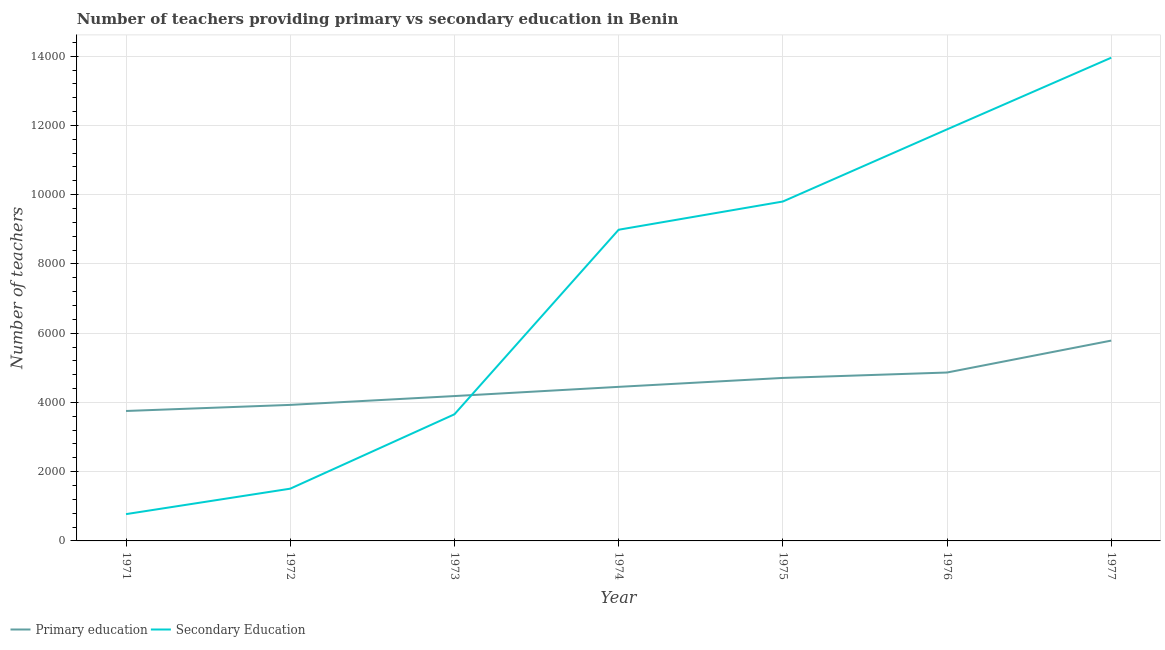Does the line corresponding to number of primary teachers intersect with the line corresponding to number of secondary teachers?
Your answer should be compact. Yes. Is the number of lines equal to the number of legend labels?
Make the answer very short. Yes. What is the number of primary teachers in 1973?
Your answer should be very brief. 4184. Across all years, what is the maximum number of primary teachers?
Give a very brief answer. 5786. Across all years, what is the minimum number of primary teachers?
Provide a short and direct response. 3753. In which year was the number of primary teachers maximum?
Give a very brief answer. 1977. What is the total number of primary teachers in the graph?
Your answer should be compact. 3.17e+04. What is the difference between the number of primary teachers in 1971 and that in 1972?
Ensure brevity in your answer.  -176. What is the difference between the number of primary teachers in 1971 and the number of secondary teachers in 1973?
Keep it short and to the point. 96. What is the average number of primary teachers per year?
Provide a succinct answer. 4524.86. In the year 1974, what is the difference between the number of secondary teachers and number of primary teachers?
Provide a short and direct response. 4538. In how many years, is the number of secondary teachers greater than 2800?
Give a very brief answer. 5. What is the ratio of the number of secondary teachers in 1972 to that in 1974?
Your response must be concise. 0.17. Is the number of primary teachers in 1971 less than that in 1974?
Your answer should be compact. Yes. Is the difference between the number of primary teachers in 1973 and 1974 greater than the difference between the number of secondary teachers in 1973 and 1974?
Your answer should be very brief. Yes. What is the difference between the highest and the second highest number of primary teachers?
Offer a terse response. 922. What is the difference between the highest and the lowest number of secondary teachers?
Provide a succinct answer. 1.32e+04. Is the number of secondary teachers strictly less than the number of primary teachers over the years?
Provide a short and direct response. No. How many lines are there?
Your response must be concise. 2. How many years are there in the graph?
Provide a short and direct response. 7. Are the values on the major ticks of Y-axis written in scientific E-notation?
Provide a succinct answer. No. Does the graph contain any zero values?
Provide a succinct answer. No. Where does the legend appear in the graph?
Make the answer very short. Bottom left. How are the legend labels stacked?
Give a very brief answer. Horizontal. What is the title of the graph?
Provide a short and direct response. Number of teachers providing primary vs secondary education in Benin. Does "Young" appear as one of the legend labels in the graph?
Give a very brief answer. No. What is the label or title of the Y-axis?
Your answer should be very brief. Number of teachers. What is the Number of teachers in Primary education in 1971?
Offer a very short reply. 3753. What is the Number of teachers in Secondary Education in 1971?
Ensure brevity in your answer.  774. What is the Number of teachers in Primary education in 1972?
Offer a terse response. 3929. What is the Number of teachers in Secondary Education in 1972?
Your response must be concise. 1509. What is the Number of teachers of Primary education in 1973?
Make the answer very short. 4184. What is the Number of teachers in Secondary Education in 1973?
Your response must be concise. 3657. What is the Number of teachers of Primary education in 1974?
Your response must be concise. 4450. What is the Number of teachers in Secondary Education in 1974?
Make the answer very short. 8988. What is the Number of teachers in Primary education in 1975?
Your answer should be compact. 4708. What is the Number of teachers in Secondary Education in 1975?
Provide a short and direct response. 9803. What is the Number of teachers of Primary education in 1976?
Keep it short and to the point. 4864. What is the Number of teachers of Secondary Education in 1976?
Make the answer very short. 1.19e+04. What is the Number of teachers in Primary education in 1977?
Your response must be concise. 5786. What is the Number of teachers in Secondary Education in 1977?
Offer a terse response. 1.40e+04. Across all years, what is the maximum Number of teachers in Primary education?
Ensure brevity in your answer.  5786. Across all years, what is the maximum Number of teachers of Secondary Education?
Your response must be concise. 1.40e+04. Across all years, what is the minimum Number of teachers in Primary education?
Make the answer very short. 3753. Across all years, what is the minimum Number of teachers of Secondary Education?
Keep it short and to the point. 774. What is the total Number of teachers in Primary education in the graph?
Offer a very short reply. 3.17e+04. What is the total Number of teachers of Secondary Education in the graph?
Ensure brevity in your answer.  5.06e+04. What is the difference between the Number of teachers of Primary education in 1971 and that in 1972?
Ensure brevity in your answer.  -176. What is the difference between the Number of teachers in Secondary Education in 1971 and that in 1972?
Offer a very short reply. -735. What is the difference between the Number of teachers of Primary education in 1971 and that in 1973?
Offer a very short reply. -431. What is the difference between the Number of teachers in Secondary Education in 1971 and that in 1973?
Provide a short and direct response. -2883. What is the difference between the Number of teachers in Primary education in 1971 and that in 1974?
Offer a terse response. -697. What is the difference between the Number of teachers of Secondary Education in 1971 and that in 1974?
Give a very brief answer. -8214. What is the difference between the Number of teachers in Primary education in 1971 and that in 1975?
Make the answer very short. -955. What is the difference between the Number of teachers in Secondary Education in 1971 and that in 1975?
Provide a succinct answer. -9029. What is the difference between the Number of teachers of Primary education in 1971 and that in 1976?
Your response must be concise. -1111. What is the difference between the Number of teachers of Secondary Education in 1971 and that in 1976?
Offer a very short reply. -1.11e+04. What is the difference between the Number of teachers of Primary education in 1971 and that in 1977?
Your answer should be compact. -2033. What is the difference between the Number of teachers of Secondary Education in 1971 and that in 1977?
Your response must be concise. -1.32e+04. What is the difference between the Number of teachers in Primary education in 1972 and that in 1973?
Give a very brief answer. -255. What is the difference between the Number of teachers of Secondary Education in 1972 and that in 1973?
Provide a short and direct response. -2148. What is the difference between the Number of teachers of Primary education in 1972 and that in 1974?
Keep it short and to the point. -521. What is the difference between the Number of teachers of Secondary Education in 1972 and that in 1974?
Your answer should be compact. -7479. What is the difference between the Number of teachers of Primary education in 1972 and that in 1975?
Your response must be concise. -779. What is the difference between the Number of teachers in Secondary Education in 1972 and that in 1975?
Your response must be concise. -8294. What is the difference between the Number of teachers in Primary education in 1972 and that in 1976?
Offer a terse response. -935. What is the difference between the Number of teachers of Secondary Education in 1972 and that in 1976?
Make the answer very short. -1.04e+04. What is the difference between the Number of teachers in Primary education in 1972 and that in 1977?
Your response must be concise. -1857. What is the difference between the Number of teachers in Secondary Education in 1972 and that in 1977?
Your answer should be very brief. -1.24e+04. What is the difference between the Number of teachers of Primary education in 1973 and that in 1974?
Make the answer very short. -266. What is the difference between the Number of teachers of Secondary Education in 1973 and that in 1974?
Ensure brevity in your answer.  -5331. What is the difference between the Number of teachers of Primary education in 1973 and that in 1975?
Your answer should be very brief. -524. What is the difference between the Number of teachers of Secondary Education in 1973 and that in 1975?
Provide a short and direct response. -6146. What is the difference between the Number of teachers in Primary education in 1973 and that in 1976?
Your response must be concise. -680. What is the difference between the Number of teachers in Secondary Education in 1973 and that in 1976?
Your answer should be very brief. -8230. What is the difference between the Number of teachers of Primary education in 1973 and that in 1977?
Your response must be concise. -1602. What is the difference between the Number of teachers of Secondary Education in 1973 and that in 1977?
Your answer should be very brief. -1.03e+04. What is the difference between the Number of teachers in Primary education in 1974 and that in 1975?
Give a very brief answer. -258. What is the difference between the Number of teachers of Secondary Education in 1974 and that in 1975?
Your response must be concise. -815. What is the difference between the Number of teachers of Primary education in 1974 and that in 1976?
Give a very brief answer. -414. What is the difference between the Number of teachers in Secondary Education in 1974 and that in 1976?
Provide a short and direct response. -2899. What is the difference between the Number of teachers of Primary education in 1974 and that in 1977?
Your answer should be very brief. -1336. What is the difference between the Number of teachers of Secondary Education in 1974 and that in 1977?
Offer a very short reply. -4969. What is the difference between the Number of teachers in Primary education in 1975 and that in 1976?
Your response must be concise. -156. What is the difference between the Number of teachers of Secondary Education in 1975 and that in 1976?
Your answer should be compact. -2084. What is the difference between the Number of teachers of Primary education in 1975 and that in 1977?
Offer a terse response. -1078. What is the difference between the Number of teachers of Secondary Education in 1975 and that in 1977?
Ensure brevity in your answer.  -4154. What is the difference between the Number of teachers of Primary education in 1976 and that in 1977?
Offer a very short reply. -922. What is the difference between the Number of teachers of Secondary Education in 1976 and that in 1977?
Offer a terse response. -2070. What is the difference between the Number of teachers of Primary education in 1971 and the Number of teachers of Secondary Education in 1972?
Offer a terse response. 2244. What is the difference between the Number of teachers of Primary education in 1971 and the Number of teachers of Secondary Education in 1973?
Offer a terse response. 96. What is the difference between the Number of teachers in Primary education in 1971 and the Number of teachers in Secondary Education in 1974?
Offer a terse response. -5235. What is the difference between the Number of teachers in Primary education in 1971 and the Number of teachers in Secondary Education in 1975?
Ensure brevity in your answer.  -6050. What is the difference between the Number of teachers of Primary education in 1971 and the Number of teachers of Secondary Education in 1976?
Your answer should be compact. -8134. What is the difference between the Number of teachers of Primary education in 1971 and the Number of teachers of Secondary Education in 1977?
Your response must be concise. -1.02e+04. What is the difference between the Number of teachers of Primary education in 1972 and the Number of teachers of Secondary Education in 1973?
Keep it short and to the point. 272. What is the difference between the Number of teachers of Primary education in 1972 and the Number of teachers of Secondary Education in 1974?
Your answer should be very brief. -5059. What is the difference between the Number of teachers in Primary education in 1972 and the Number of teachers in Secondary Education in 1975?
Your answer should be very brief. -5874. What is the difference between the Number of teachers in Primary education in 1972 and the Number of teachers in Secondary Education in 1976?
Offer a terse response. -7958. What is the difference between the Number of teachers in Primary education in 1972 and the Number of teachers in Secondary Education in 1977?
Your answer should be compact. -1.00e+04. What is the difference between the Number of teachers in Primary education in 1973 and the Number of teachers in Secondary Education in 1974?
Make the answer very short. -4804. What is the difference between the Number of teachers of Primary education in 1973 and the Number of teachers of Secondary Education in 1975?
Your response must be concise. -5619. What is the difference between the Number of teachers in Primary education in 1973 and the Number of teachers in Secondary Education in 1976?
Keep it short and to the point. -7703. What is the difference between the Number of teachers of Primary education in 1973 and the Number of teachers of Secondary Education in 1977?
Ensure brevity in your answer.  -9773. What is the difference between the Number of teachers in Primary education in 1974 and the Number of teachers in Secondary Education in 1975?
Your response must be concise. -5353. What is the difference between the Number of teachers of Primary education in 1974 and the Number of teachers of Secondary Education in 1976?
Your answer should be compact. -7437. What is the difference between the Number of teachers of Primary education in 1974 and the Number of teachers of Secondary Education in 1977?
Offer a very short reply. -9507. What is the difference between the Number of teachers in Primary education in 1975 and the Number of teachers in Secondary Education in 1976?
Offer a very short reply. -7179. What is the difference between the Number of teachers of Primary education in 1975 and the Number of teachers of Secondary Education in 1977?
Your response must be concise. -9249. What is the difference between the Number of teachers of Primary education in 1976 and the Number of teachers of Secondary Education in 1977?
Keep it short and to the point. -9093. What is the average Number of teachers of Primary education per year?
Your answer should be very brief. 4524.86. What is the average Number of teachers in Secondary Education per year?
Make the answer very short. 7225. In the year 1971, what is the difference between the Number of teachers in Primary education and Number of teachers in Secondary Education?
Ensure brevity in your answer.  2979. In the year 1972, what is the difference between the Number of teachers of Primary education and Number of teachers of Secondary Education?
Keep it short and to the point. 2420. In the year 1973, what is the difference between the Number of teachers in Primary education and Number of teachers in Secondary Education?
Offer a very short reply. 527. In the year 1974, what is the difference between the Number of teachers of Primary education and Number of teachers of Secondary Education?
Provide a succinct answer. -4538. In the year 1975, what is the difference between the Number of teachers in Primary education and Number of teachers in Secondary Education?
Your response must be concise. -5095. In the year 1976, what is the difference between the Number of teachers in Primary education and Number of teachers in Secondary Education?
Give a very brief answer. -7023. In the year 1977, what is the difference between the Number of teachers in Primary education and Number of teachers in Secondary Education?
Give a very brief answer. -8171. What is the ratio of the Number of teachers of Primary education in 1971 to that in 1972?
Ensure brevity in your answer.  0.96. What is the ratio of the Number of teachers in Secondary Education in 1971 to that in 1972?
Provide a succinct answer. 0.51. What is the ratio of the Number of teachers of Primary education in 1971 to that in 1973?
Ensure brevity in your answer.  0.9. What is the ratio of the Number of teachers of Secondary Education in 1971 to that in 1973?
Your response must be concise. 0.21. What is the ratio of the Number of teachers in Primary education in 1971 to that in 1974?
Offer a very short reply. 0.84. What is the ratio of the Number of teachers of Secondary Education in 1971 to that in 1974?
Your response must be concise. 0.09. What is the ratio of the Number of teachers of Primary education in 1971 to that in 1975?
Provide a succinct answer. 0.8. What is the ratio of the Number of teachers in Secondary Education in 1971 to that in 1975?
Offer a very short reply. 0.08. What is the ratio of the Number of teachers of Primary education in 1971 to that in 1976?
Your answer should be very brief. 0.77. What is the ratio of the Number of teachers of Secondary Education in 1971 to that in 1976?
Provide a succinct answer. 0.07. What is the ratio of the Number of teachers of Primary education in 1971 to that in 1977?
Provide a succinct answer. 0.65. What is the ratio of the Number of teachers in Secondary Education in 1971 to that in 1977?
Offer a very short reply. 0.06. What is the ratio of the Number of teachers of Primary education in 1972 to that in 1973?
Your response must be concise. 0.94. What is the ratio of the Number of teachers of Secondary Education in 1972 to that in 1973?
Your answer should be very brief. 0.41. What is the ratio of the Number of teachers in Primary education in 1972 to that in 1974?
Your response must be concise. 0.88. What is the ratio of the Number of teachers in Secondary Education in 1972 to that in 1974?
Your answer should be very brief. 0.17. What is the ratio of the Number of teachers of Primary education in 1972 to that in 1975?
Your answer should be compact. 0.83. What is the ratio of the Number of teachers in Secondary Education in 1972 to that in 1975?
Your answer should be very brief. 0.15. What is the ratio of the Number of teachers in Primary education in 1972 to that in 1976?
Your answer should be compact. 0.81. What is the ratio of the Number of teachers in Secondary Education in 1972 to that in 1976?
Keep it short and to the point. 0.13. What is the ratio of the Number of teachers in Primary education in 1972 to that in 1977?
Offer a terse response. 0.68. What is the ratio of the Number of teachers of Secondary Education in 1972 to that in 1977?
Your answer should be very brief. 0.11. What is the ratio of the Number of teachers of Primary education in 1973 to that in 1974?
Ensure brevity in your answer.  0.94. What is the ratio of the Number of teachers of Secondary Education in 1973 to that in 1974?
Ensure brevity in your answer.  0.41. What is the ratio of the Number of teachers in Primary education in 1973 to that in 1975?
Your answer should be very brief. 0.89. What is the ratio of the Number of teachers of Secondary Education in 1973 to that in 1975?
Offer a terse response. 0.37. What is the ratio of the Number of teachers in Primary education in 1973 to that in 1976?
Provide a succinct answer. 0.86. What is the ratio of the Number of teachers in Secondary Education in 1973 to that in 1976?
Ensure brevity in your answer.  0.31. What is the ratio of the Number of teachers of Primary education in 1973 to that in 1977?
Your answer should be compact. 0.72. What is the ratio of the Number of teachers in Secondary Education in 1973 to that in 1977?
Offer a very short reply. 0.26. What is the ratio of the Number of teachers of Primary education in 1974 to that in 1975?
Your answer should be compact. 0.95. What is the ratio of the Number of teachers of Secondary Education in 1974 to that in 1975?
Ensure brevity in your answer.  0.92. What is the ratio of the Number of teachers of Primary education in 1974 to that in 1976?
Make the answer very short. 0.91. What is the ratio of the Number of teachers of Secondary Education in 1974 to that in 1976?
Give a very brief answer. 0.76. What is the ratio of the Number of teachers of Primary education in 1974 to that in 1977?
Your answer should be very brief. 0.77. What is the ratio of the Number of teachers in Secondary Education in 1974 to that in 1977?
Your response must be concise. 0.64. What is the ratio of the Number of teachers of Primary education in 1975 to that in 1976?
Offer a terse response. 0.97. What is the ratio of the Number of teachers in Secondary Education in 1975 to that in 1976?
Make the answer very short. 0.82. What is the ratio of the Number of teachers of Primary education in 1975 to that in 1977?
Provide a succinct answer. 0.81. What is the ratio of the Number of teachers in Secondary Education in 1975 to that in 1977?
Keep it short and to the point. 0.7. What is the ratio of the Number of teachers of Primary education in 1976 to that in 1977?
Offer a terse response. 0.84. What is the ratio of the Number of teachers in Secondary Education in 1976 to that in 1977?
Make the answer very short. 0.85. What is the difference between the highest and the second highest Number of teachers of Primary education?
Give a very brief answer. 922. What is the difference between the highest and the second highest Number of teachers of Secondary Education?
Make the answer very short. 2070. What is the difference between the highest and the lowest Number of teachers of Primary education?
Offer a very short reply. 2033. What is the difference between the highest and the lowest Number of teachers in Secondary Education?
Offer a very short reply. 1.32e+04. 